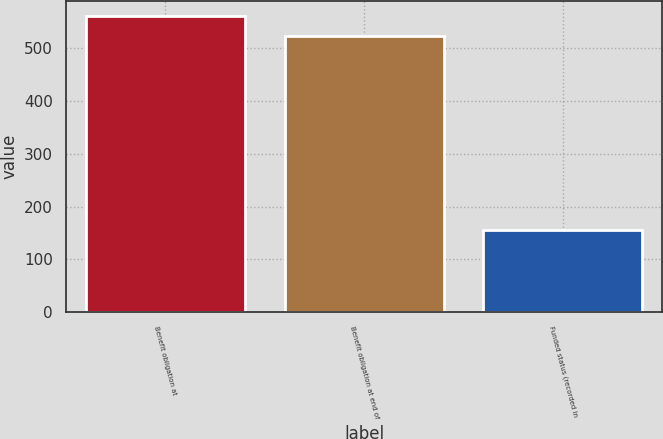Convert chart to OTSL. <chart><loc_0><loc_0><loc_500><loc_500><bar_chart><fcel>Benefit obligation at<fcel>Benefit obligation at end of<fcel>Funded status (recorded in<nl><fcel>561<fcel>523<fcel>155<nl></chart> 